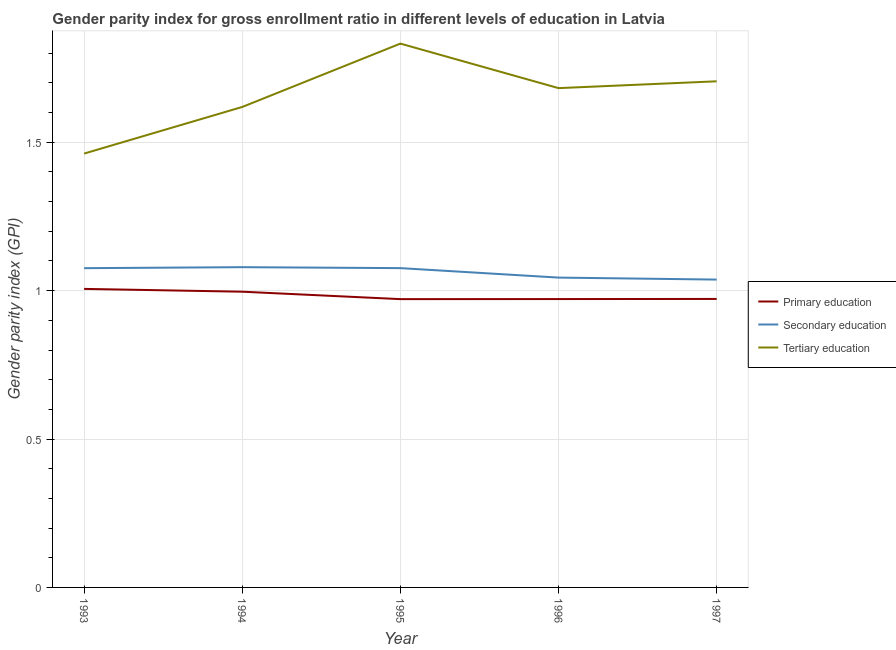Is the number of lines equal to the number of legend labels?
Make the answer very short. Yes. What is the gender parity index in primary education in 1995?
Make the answer very short. 0.97. Across all years, what is the maximum gender parity index in secondary education?
Offer a terse response. 1.08. Across all years, what is the minimum gender parity index in tertiary education?
Your response must be concise. 1.46. In which year was the gender parity index in secondary education maximum?
Your answer should be very brief. 1994. In which year was the gender parity index in secondary education minimum?
Offer a terse response. 1997. What is the total gender parity index in tertiary education in the graph?
Your answer should be very brief. 8.3. What is the difference between the gender parity index in primary education in 1995 and that in 1997?
Offer a very short reply. -0. What is the difference between the gender parity index in tertiary education in 1997 and the gender parity index in secondary education in 1994?
Offer a very short reply. 0.63. What is the average gender parity index in tertiary education per year?
Keep it short and to the point. 1.66. In the year 1996, what is the difference between the gender parity index in secondary education and gender parity index in primary education?
Ensure brevity in your answer.  0.07. What is the ratio of the gender parity index in primary education in 1993 to that in 1995?
Keep it short and to the point. 1.04. What is the difference between the highest and the second highest gender parity index in tertiary education?
Offer a terse response. 0.13. What is the difference between the highest and the lowest gender parity index in secondary education?
Give a very brief answer. 0.04. Is the sum of the gender parity index in tertiary education in 1995 and 1997 greater than the maximum gender parity index in secondary education across all years?
Offer a terse response. Yes. How many lines are there?
Your answer should be very brief. 3. How many years are there in the graph?
Your answer should be very brief. 5. What is the difference between two consecutive major ticks on the Y-axis?
Provide a succinct answer. 0.5. Are the values on the major ticks of Y-axis written in scientific E-notation?
Your answer should be compact. No. What is the title of the graph?
Your response must be concise. Gender parity index for gross enrollment ratio in different levels of education in Latvia. Does "Machinery" appear as one of the legend labels in the graph?
Provide a succinct answer. No. What is the label or title of the Y-axis?
Your answer should be very brief. Gender parity index (GPI). What is the Gender parity index (GPI) of Primary education in 1993?
Give a very brief answer. 1.01. What is the Gender parity index (GPI) in Secondary education in 1993?
Make the answer very short. 1.08. What is the Gender parity index (GPI) in Tertiary education in 1993?
Offer a very short reply. 1.46. What is the Gender parity index (GPI) of Primary education in 1994?
Provide a short and direct response. 1. What is the Gender parity index (GPI) of Secondary education in 1994?
Ensure brevity in your answer.  1.08. What is the Gender parity index (GPI) of Tertiary education in 1994?
Your response must be concise. 1.62. What is the Gender parity index (GPI) in Primary education in 1995?
Your answer should be very brief. 0.97. What is the Gender parity index (GPI) in Secondary education in 1995?
Keep it short and to the point. 1.08. What is the Gender parity index (GPI) of Tertiary education in 1995?
Your answer should be compact. 1.83. What is the Gender parity index (GPI) in Primary education in 1996?
Make the answer very short. 0.97. What is the Gender parity index (GPI) of Secondary education in 1996?
Your answer should be compact. 1.04. What is the Gender parity index (GPI) of Tertiary education in 1996?
Provide a short and direct response. 1.68. What is the Gender parity index (GPI) in Primary education in 1997?
Provide a short and direct response. 0.97. What is the Gender parity index (GPI) in Secondary education in 1997?
Your answer should be compact. 1.04. What is the Gender parity index (GPI) of Tertiary education in 1997?
Your answer should be very brief. 1.71. Across all years, what is the maximum Gender parity index (GPI) in Primary education?
Keep it short and to the point. 1.01. Across all years, what is the maximum Gender parity index (GPI) of Secondary education?
Your answer should be very brief. 1.08. Across all years, what is the maximum Gender parity index (GPI) in Tertiary education?
Keep it short and to the point. 1.83. Across all years, what is the minimum Gender parity index (GPI) in Primary education?
Provide a short and direct response. 0.97. Across all years, what is the minimum Gender parity index (GPI) in Secondary education?
Ensure brevity in your answer.  1.04. Across all years, what is the minimum Gender parity index (GPI) in Tertiary education?
Your answer should be very brief. 1.46. What is the total Gender parity index (GPI) in Primary education in the graph?
Offer a terse response. 4.92. What is the total Gender parity index (GPI) in Secondary education in the graph?
Your response must be concise. 5.31. What is the total Gender parity index (GPI) of Tertiary education in the graph?
Your response must be concise. 8.3. What is the difference between the Gender parity index (GPI) of Primary education in 1993 and that in 1994?
Provide a succinct answer. 0.01. What is the difference between the Gender parity index (GPI) in Secondary education in 1993 and that in 1994?
Provide a short and direct response. -0. What is the difference between the Gender parity index (GPI) of Tertiary education in 1993 and that in 1994?
Your answer should be compact. -0.16. What is the difference between the Gender parity index (GPI) of Primary education in 1993 and that in 1995?
Make the answer very short. 0.03. What is the difference between the Gender parity index (GPI) in Secondary education in 1993 and that in 1995?
Offer a terse response. -0. What is the difference between the Gender parity index (GPI) of Tertiary education in 1993 and that in 1995?
Your answer should be compact. -0.37. What is the difference between the Gender parity index (GPI) of Primary education in 1993 and that in 1996?
Your response must be concise. 0.03. What is the difference between the Gender parity index (GPI) of Secondary education in 1993 and that in 1996?
Ensure brevity in your answer.  0.03. What is the difference between the Gender parity index (GPI) in Tertiary education in 1993 and that in 1996?
Provide a succinct answer. -0.22. What is the difference between the Gender parity index (GPI) in Primary education in 1993 and that in 1997?
Make the answer very short. 0.03. What is the difference between the Gender parity index (GPI) in Secondary education in 1993 and that in 1997?
Offer a very short reply. 0.04. What is the difference between the Gender parity index (GPI) in Tertiary education in 1993 and that in 1997?
Your response must be concise. -0.24. What is the difference between the Gender parity index (GPI) in Primary education in 1994 and that in 1995?
Your response must be concise. 0.03. What is the difference between the Gender parity index (GPI) of Secondary education in 1994 and that in 1995?
Offer a very short reply. 0. What is the difference between the Gender parity index (GPI) in Tertiary education in 1994 and that in 1995?
Make the answer very short. -0.21. What is the difference between the Gender parity index (GPI) in Primary education in 1994 and that in 1996?
Make the answer very short. 0.02. What is the difference between the Gender parity index (GPI) of Secondary education in 1994 and that in 1996?
Your response must be concise. 0.04. What is the difference between the Gender parity index (GPI) of Tertiary education in 1994 and that in 1996?
Offer a terse response. -0.06. What is the difference between the Gender parity index (GPI) in Primary education in 1994 and that in 1997?
Offer a terse response. 0.02. What is the difference between the Gender parity index (GPI) in Secondary education in 1994 and that in 1997?
Make the answer very short. 0.04. What is the difference between the Gender parity index (GPI) in Tertiary education in 1994 and that in 1997?
Provide a short and direct response. -0.09. What is the difference between the Gender parity index (GPI) in Primary education in 1995 and that in 1996?
Your answer should be very brief. -0. What is the difference between the Gender parity index (GPI) in Secondary education in 1995 and that in 1996?
Offer a terse response. 0.03. What is the difference between the Gender parity index (GPI) in Primary education in 1995 and that in 1997?
Offer a terse response. -0. What is the difference between the Gender parity index (GPI) in Secondary education in 1995 and that in 1997?
Your answer should be very brief. 0.04. What is the difference between the Gender parity index (GPI) in Tertiary education in 1995 and that in 1997?
Offer a terse response. 0.13. What is the difference between the Gender parity index (GPI) of Primary education in 1996 and that in 1997?
Provide a succinct answer. -0. What is the difference between the Gender parity index (GPI) of Secondary education in 1996 and that in 1997?
Your response must be concise. 0.01. What is the difference between the Gender parity index (GPI) in Tertiary education in 1996 and that in 1997?
Your answer should be very brief. -0.02. What is the difference between the Gender parity index (GPI) of Primary education in 1993 and the Gender parity index (GPI) of Secondary education in 1994?
Your answer should be compact. -0.07. What is the difference between the Gender parity index (GPI) of Primary education in 1993 and the Gender parity index (GPI) of Tertiary education in 1994?
Your response must be concise. -0.61. What is the difference between the Gender parity index (GPI) in Secondary education in 1993 and the Gender parity index (GPI) in Tertiary education in 1994?
Offer a very short reply. -0.54. What is the difference between the Gender parity index (GPI) of Primary education in 1993 and the Gender parity index (GPI) of Secondary education in 1995?
Your answer should be very brief. -0.07. What is the difference between the Gender parity index (GPI) of Primary education in 1993 and the Gender parity index (GPI) of Tertiary education in 1995?
Give a very brief answer. -0.83. What is the difference between the Gender parity index (GPI) in Secondary education in 1993 and the Gender parity index (GPI) in Tertiary education in 1995?
Your answer should be very brief. -0.76. What is the difference between the Gender parity index (GPI) in Primary education in 1993 and the Gender parity index (GPI) in Secondary education in 1996?
Your response must be concise. -0.04. What is the difference between the Gender parity index (GPI) in Primary education in 1993 and the Gender parity index (GPI) in Tertiary education in 1996?
Give a very brief answer. -0.68. What is the difference between the Gender parity index (GPI) of Secondary education in 1993 and the Gender parity index (GPI) of Tertiary education in 1996?
Your answer should be compact. -0.61. What is the difference between the Gender parity index (GPI) of Primary education in 1993 and the Gender parity index (GPI) of Secondary education in 1997?
Ensure brevity in your answer.  -0.03. What is the difference between the Gender parity index (GPI) of Primary education in 1993 and the Gender parity index (GPI) of Tertiary education in 1997?
Your answer should be very brief. -0.7. What is the difference between the Gender parity index (GPI) of Secondary education in 1993 and the Gender parity index (GPI) of Tertiary education in 1997?
Provide a short and direct response. -0.63. What is the difference between the Gender parity index (GPI) in Primary education in 1994 and the Gender parity index (GPI) in Secondary education in 1995?
Keep it short and to the point. -0.08. What is the difference between the Gender parity index (GPI) of Primary education in 1994 and the Gender parity index (GPI) of Tertiary education in 1995?
Offer a terse response. -0.84. What is the difference between the Gender parity index (GPI) of Secondary education in 1994 and the Gender parity index (GPI) of Tertiary education in 1995?
Provide a succinct answer. -0.75. What is the difference between the Gender parity index (GPI) of Primary education in 1994 and the Gender parity index (GPI) of Secondary education in 1996?
Your answer should be compact. -0.05. What is the difference between the Gender parity index (GPI) in Primary education in 1994 and the Gender parity index (GPI) in Tertiary education in 1996?
Your answer should be compact. -0.69. What is the difference between the Gender parity index (GPI) of Secondary education in 1994 and the Gender parity index (GPI) of Tertiary education in 1996?
Your answer should be very brief. -0.6. What is the difference between the Gender parity index (GPI) of Primary education in 1994 and the Gender parity index (GPI) of Secondary education in 1997?
Make the answer very short. -0.04. What is the difference between the Gender parity index (GPI) of Primary education in 1994 and the Gender parity index (GPI) of Tertiary education in 1997?
Keep it short and to the point. -0.71. What is the difference between the Gender parity index (GPI) in Secondary education in 1994 and the Gender parity index (GPI) in Tertiary education in 1997?
Ensure brevity in your answer.  -0.63. What is the difference between the Gender parity index (GPI) of Primary education in 1995 and the Gender parity index (GPI) of Secondary education in 1996?
Offer a very short reply. -0.07. What is the difference between the Gender parity index (GPI) in Primary education in 1995 and the Gender parity index (GPI) in Tertiary education in 1996?
Ensure brevity in your answer.  -0.71. What is the difference between the Gender parity index (GPI) in Secondary education in 1995 and the Gender parity index (GPI) in Tertiary education in 1996?
Offer a very short reply. -0.61. What is the difference between the Gender parity index (GPI) in Primary education in 1995 and the Gender parity index (GPI) in Secondary education in 1997?
Your answer should be compact. -0.07. What is the difference between the Gender parity index (GPI) in Primary education in 1995 and the Gender parity index (GPI) in Tertiary education in 1997?
Provide a short and direct response. -0.73. What is the difference between the Gender parity index (GPI) in Secondary education in 1995 and the Gender parity index (GPI) in Tertiary education in 1997?
Make the answer very short. -0.63. What is the difference between the Gender parity index (GPI) of Primary education in 1996 and the Gender parity index (GPI) of Secondary education in 1997?
Offer a terse response. -0.07. What is the difference between the Gender parity index (GPI) of Primary education in 1996 and the Gender parity index (GPI) of Tertiary education in 1997?
Offer a very short reply. -0.73. What is the difference between the Gender parity index (GPI) of Secondary education in 1996 and the Gender parity index (GPI) of Tertiary education in 1997?
Your answer should be very brief. -0.66. What is the average Gender parity index (GPI) in Primary education per year?
Keep it short and to the point. 0.98. What is the average Gender parity index (GPI) in Secondary education per year?
Make the answer very short. 1.06. What is the average Gender parity index (GPI) in Tertiary education per year?
Keep it short and to the point. 1.66. In the year 1993, what is the difference between the Gender parity index (GPI) in Primary education and Gender parity index (GPI) in Secondary education?
Offer a very short reply. -0.07. In the year 1993, what is the difference between the Gender parity index (GPI) in Primary education and Gender parity index (GPI) in Tertiary education?
Your answer should be very brief. -0.46. In the year 1993, what is the difference between the Gender parity index (GPI) of Secondary education and Gender parity index (GPI) of Tertiary education?
Offer a very short reply. -0.39. In the year 1994, what is the difference between the Gender parity index (GPI) in Primary education and Gender parity index (GPI) in Secondary education?
Keep it short and to the point. -0.08. In the year 1994, what is the difference between the Gender parity index (GPI) in Primary education and Gender parity index (GPI) in Tertiary education?
Offer a very short reply. -0.62. In the year 1994, what is the difference between the Gender parity index (GPI) of Secondary education and Gender parity index (GPI) of Tertiary education?
Your response must be concise. -0.54. In the year 1995, what is the difference between the Gender parity index (GPI) of Primary education and Gender parity index (GPI) of Secondary education?
Offer a terse response. -0.1. In the year 1995, what is the difference between the Gender parity index (GPI) of Primary education and Gender parity index (GPI) of Tertiary education?
Your response must be concise. -0.86. In the year 1995, what is the difference between the Gender parity index (GPI) of Secondary education and Gender parity index (GPI) of Tertiary education?
Offer a very short reply. -0.76. In the year 1996, what is the difference between the Gender parity index (GPI) of Primary education and Gender parity index (GPI) of Secondary education?
Provide a short and direct response. -0.07. In the year 1996, what is the difference between the Gender parity index (GPI) in Primary education and Gender parity index (GPI) in Tertiary education?
Provide a succinct answer. -0.71. In the year 1996, what is the difference between the Gender parity index (GPI) of Secondary education and Gender parity index (GPI) of Tertiary education?
Your response must be concise. -0.64. In the year 1997, what is the difference between the Gender parity index (GPI) of Primary education and Gender parity index (GPI) of Secondary education?
Give a very brief answer. -0.07. In the year 1997, what is the difference between the Gender parity index (GPI) of Primary education and Gender parity index (GPI) of Tertiary education?
Ensure brevity in your answer.  -0.73. In the year 1997, what is the difference between the Gender parity index (GPI) in Secondary education and Gender parity index (GPI) in Tertiary education?
Provide a succinct answer. -0.67. What is the ratio of the Gender parity index (GPI) of Primary education in 1993 to that in 1994?
Your answer should be very brief. 1.01. What is the ratio of the Gender parity index (GPI) in Tertiary education in 1993 to that in 1994?
Ensure brevity in your answer.  0.9. What is the ratio of the Gender parity index (GPI) in Primary education in 1993 to that in 1995?
Provide a succinct answer. 1.04. What is the ratio of the Gender parity index (GPI) of Tertiary education in 1993 to that in 1995?
Your answer should be very brief. 0.8. What is the ratio of the Gender parity index (GPI) of Primary education in 1993 to that in 1996?
Make the answer very short. 1.04. What is the ratio of the Gender parity index (GPI) of Secondary education in 1993 to that in 1996?
Give a very brief answer. 1.03. What is the ratio of the Gender parity index (GPI) in Tertiary education in 1993 to that in 1996?
Provide a succinct answer. 0.87. What is the ratio of the Gender parity index (GPI) in Primary education in 1993 to that in 1997?
Provide a succinct answer. 1.03. What is the ratio of the Gender parity index (GPI) of Secondary education in 1993 to that in 1997?
Keep it short and to the point. 1.04. What is the ratio of the Gender parity index (GPI) of Tertiary education in 1993 to that in 1997?
Keep it short and to the point. 0.86. What is the ratio of the Gender parity index (GPI) in Primary education in 1994 to that in 1995?
Your answer should be very brief. 1.03. What is the ratio of the Gender parity index (GPI) in Tertiary education in 1994 to that in 1995?
Ensure brevity in your answer.  0.88. What is the ratio of the Gender parity index (GPI) in Primary education in 1994 to that in 1996?
Your answer should be compact. 1.03. What is the ratio of the Gender parity index (GPI) of Secondary education in 1994 to that in 1996?
Offer a terse response. 1.03. What is the ratio of the Gender parity index (GPI) of Tertiary education in 1994 to that in 1996?
Your answer should be compact. 0.96. What is the ratio of the Gender parity index (GPI) of Primary education in 1994 to that in 1997?
Offer a very short reply. 1.03. What is the ratio of the Gender parity index (GPI) in Secondary education in 1994 to that in 1997?
Offer a very short reply. 1.04. What is the ratio of the Gender parity index (GPI) in Tertiary education in 1994 to that in 1997?
Your answer should be very brief. 0.95. What is the ratio of the Gender parity index (GPI) in Primary education in 1995 to that in 1996?
Ensure brevity in your answer.  1. What is the ratio of the Gender parity index (GPI) in Secondary education in 1995 to that in 1996?
Give a very brief answer. 1.03. What is the ratio of the Gender parity index (GPI) in Tertiary education in 1995 to that in 1996?
Make the answer very short. 1.09. What is the ratio of the Gender parity index (GPI) in Secondary education in 1995 to that in 1997?
Your response must be concise. 1.04. What is the ratio of the Gender parity index (GPI) in Tertiary education in 1995 to that in 1997?
Give a very brief answer. 1.07. What is the ratio of the Gender parity index (GPI) of Primary education in 1996 to that in 1997?
Provide a succinct answer. 1. What is the ratio of the Gender parity index (GPI) in Secondary education in 1996 to that in 1997?
Keep it short and to the point. 1.01. What is the ratio of the Gender parity index (GPI) in Tertiary education in 1996 to that in 1997?
Offer a terse response. 0.99. What is the difference between the highest and the second highest Gender parity index (GPI) of Primary education?
Provide a short and direct response. 0.01. What is the difference between the highest and the second highest Gender parity index (GPI) in Secondary education?
Your answer should be compact. 0. What is the difference between the highest and the second highest Gender parity index (GPI) in Tertiary education?
Your response must be concise. 0.13. What is the difference between the highest and the lowest Gender parity index (GPI) of Primary education?
Keep it short and to the point. 0.03. What is the difference between the highest and the lowest Gender parity index (GPI) of Secondary education?
Your answer should be very brief. 0.04. What is the difference between the highest and the lowest Gender parity index (GPI) in Tertiary education?
Your answer should be very brief. 0.37. 